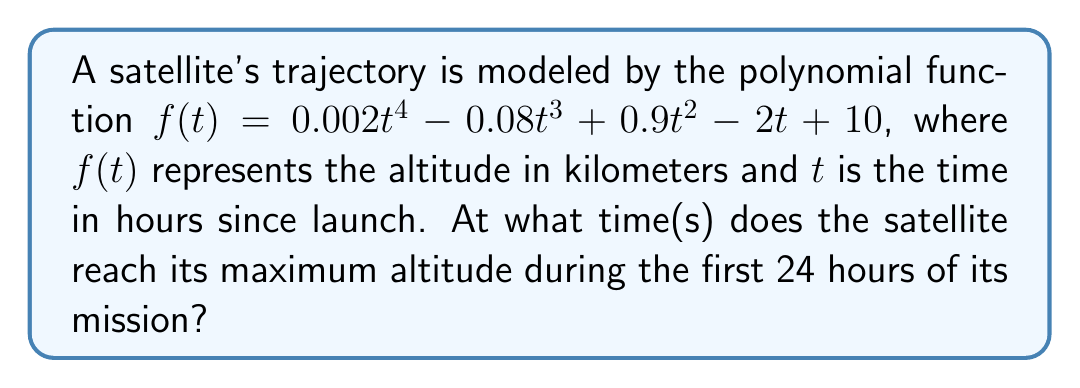Provide a solution to this math problem. To find the maximum altitude, we need to determine where the derivative of the function equals zero:

1) First, calculate the derivative:
   $f'(t) = 0.008t^3 - 0.24t^2 + 1.8t - 2$

2) Set the derivative equal to zero:
   $0.008t^3 - 0.24t^2 + 1.8t - 2 = 0$

3) This is a cubic equation. We can solve it using the cubic formula or a graphing calculator. The solutions are:
   $t ≈ 1.37, 10.63, 18.00$

4) To confirm these are maxima (not minima), we can check the second derivative:
   $f''(t) = 0.024t^2 - 0.48t + 1.8$

5) Evaluating $f''(t)$ at each critical point:
   $f''(1.37) ≈ 1.29 > 0$ (local minimum)
   $f''(10.63) ≈ -0.77 < 0$ (local maximum)
   $f''(18.00) ≈ 1.30 > 0$ (local minimum)

6) Since we're only interested in the first 24 hours, the maximum occurs at $t ≈ 10.63$ hours.
Answer: 10.63 hours 